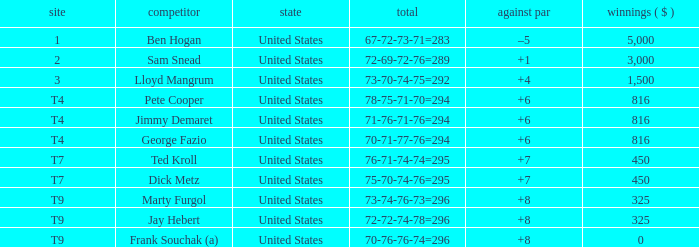How much was paid to the player whose score was 70-71-77-76=294? 816.0. 